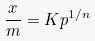Convert formula to latex. <formula><loc_0><loc_0><loc_500><loc_500>\frac { x } { m } = K p ^ { 1 / n }</formula> 